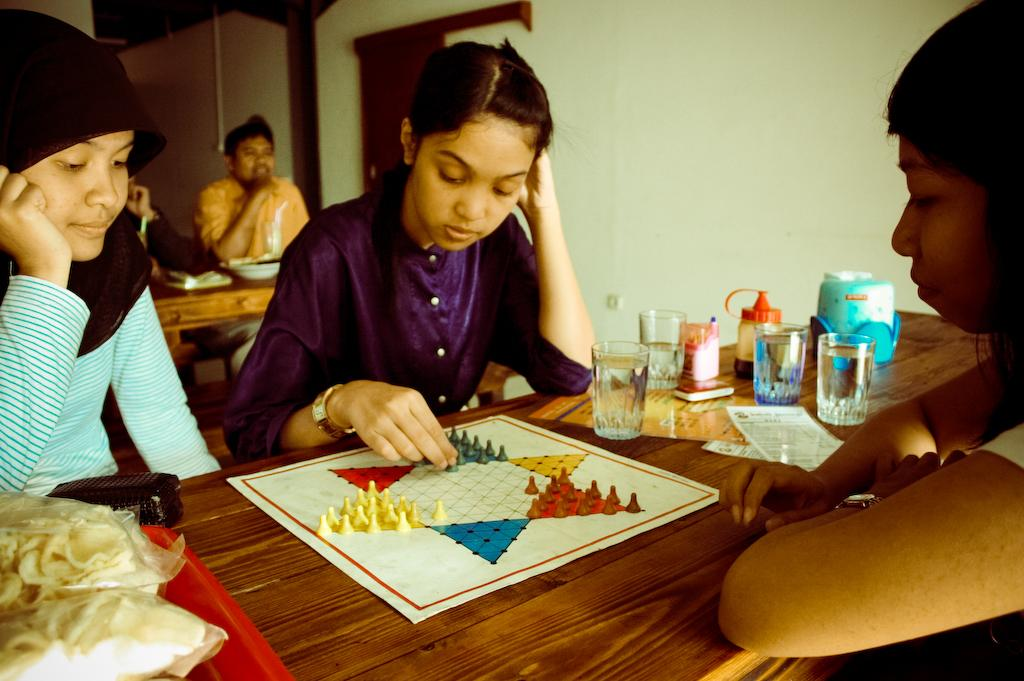What are the people in the image doing? The people in the image are sitting on chairs and playing a game. What is on the table in the image? There is a tray, a glass, a paper, and a box on the table. How many chairs are visible in the image? The number of chairs is not specified, but there are people sitting on chairs in the image. What is the purpose of the tray on the table? The purpose of the tray on the table is not specified, but it is likely being used to hold or organize items. What type of health benefits can be found in the clam on the table? There is no clam present in the image; it only mentions a tray, a glass, a paper, and a box on the table. How deep is the cave in the image? There is no cave present in the image; it only shows people sitting on chairs and a table with various items on it. 